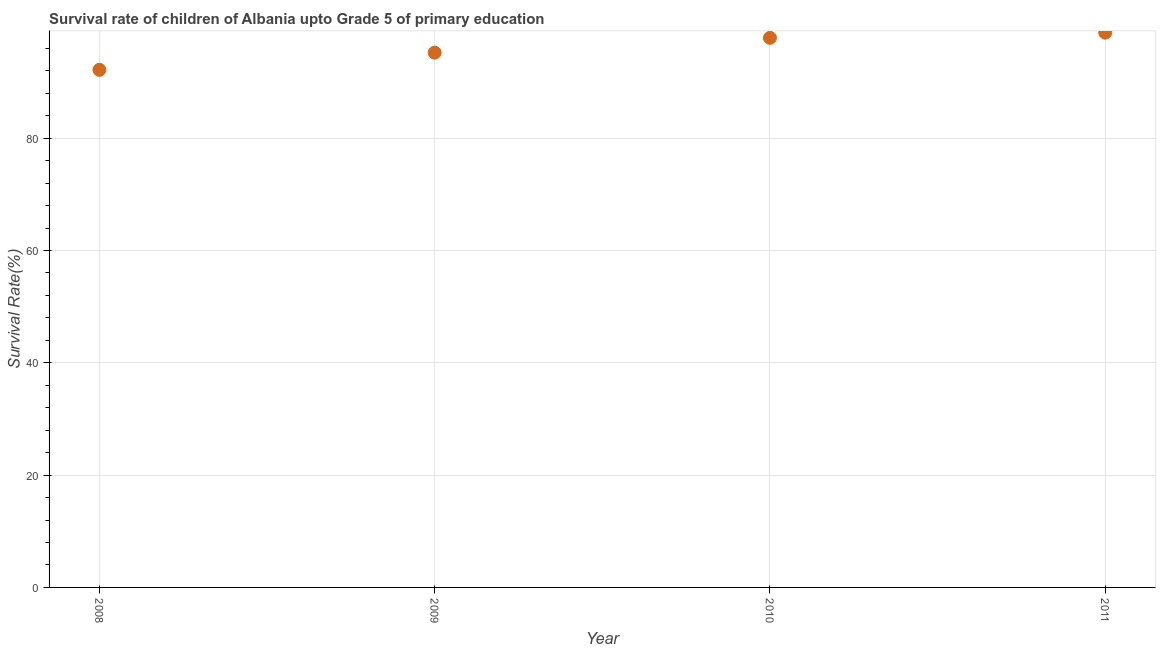What is the survival rate in 2011?
Your response must be concise. 98.78. Across all years, what is the maximum survival rate?
Offer a very short reply. 98.78. Across all years, what is the minimum survival rate?
Your answer should be very brief. 92.17. In which year was the survival rate maximum?
Make the answer very short. 2011. In which year was the survival rate minimum?
Give a very brief answer. 2008. What is the sum of the survival rate?
Your answer should be very brief. 384.05. What is the difference between the survival rate in 2010 and 2011?
Make the answer very short. -0.92. What is the average survival rate per year?
Offer a terse response. 96.01. What is the median survival rate?
Provide a succinct answer. 96.55. What is the ratio of the survival rate in 2009 to that in 2011?
Your answer should be very brief. 0.96. Is the survival rate in 2008 less than that in 2010?
Keep it short and to the point. Yes. Is the difference between the survival rate in 2009 and 2010 greater than the difference between any two years?
Provide a succinct answer. No. What is the difference between the highest and the second highest survival rate?
Make the answer very short. 0.92. Is the sum of the survival rate in 2008 and 2009 greater than the maximum survival rate across all years?
Your response must be concise. Yes. What is the difference between the highest and the lowest survival rate?
Provide a succinct answer. 6.61. In how many years, is the survival rate greater than the average survival rate taken over all years?
Your answer should be compact. 2. Does the survival rate monotonically increase over the years?
Keep it short and to the point. Yes. Are the values on the major ticks of Y-axis written in scientific E-notation?
Offer a terse response. No. Does the graph contain any zero values?
Your answer should be compact. No. What is the title of the graph?
Your response must be concise. Survival rate of children of Albania upto Grade 5 of primary education. What is the label or title of the Y-axis?
Make the answer very short. Survival Rate(%). What is the Survival Rate(%) in 2008?
Provide a succinct answer. 92.17. What is the Survival Rate(%) in 2009?
Keep it short and to the point. 95.23. What is the Survival Rate(%) in 2010?
Provide a short and direct response. 97.86. What is the Survival Rate(%) in 2011?
Ensure brevity in your answer.  98.78. What is the difference between the Survival Rate(%) in 2008 and 2009?
Make the answer very short. -3.06. What is the difference between the Survival Rate(%) in 2008 and 2010?
Provide a short and direct response. -5.69. What is the difference between the Survival Rate(%) in 2008 and 2011?
Offer a very short reply. -6.61. What is the difference between the Survival Rate(%) in 2009 and 2010?
Offer a very short reply. -2.64. What is the difference between the Survival Rate(%) in 2009 and 2011?
Your response must be concise. -3.55. What is the difference between the Survival Rate(%) in 2010 and 2011?
Keep it short and to the point. -0.92. What is the ratio of the Survival Rate(%) in 2008 to that in 2010?
Make the answer very short. 0.94. What is the ratio of the Survival Rate(%) in 2008 to that in 2011?
Offer a very short reply. 0.93. What is the ratio of the Survival Rate(%) in 2009 to that in 2010?
Your answer should be very brief. 0.97. What is the ratio of the Survival Rate(%) in 2009 to that in 2011?
Give a very brief answer. 0.96. What is the ratio of the Survival Rate(%) in 2010 to that in 2011?
Your answer should be compact. 0.99. 